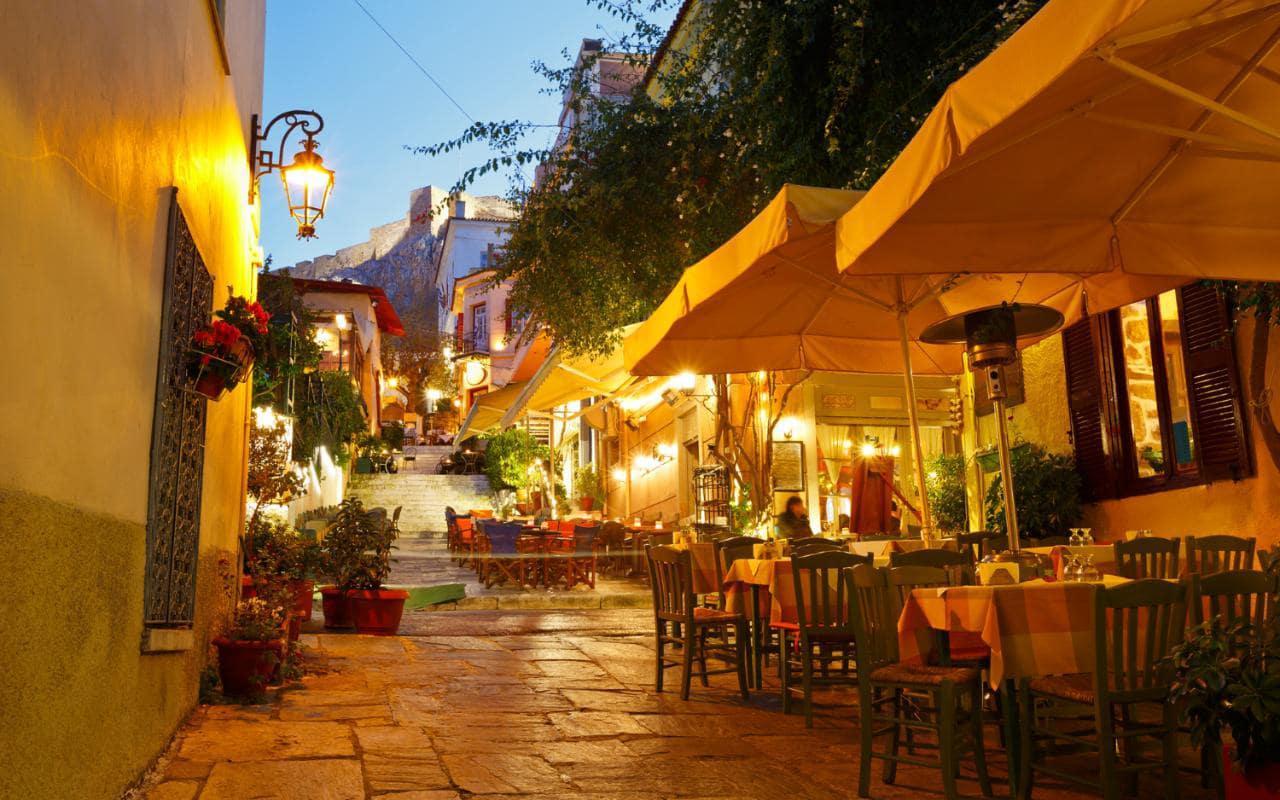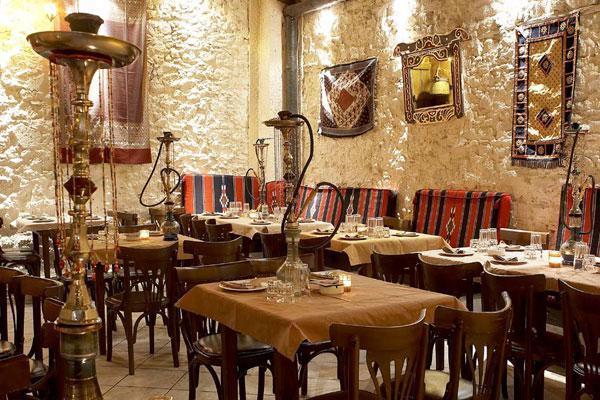The first image is the image on the left, the second image is the image on the right. Given the left and right images, does the statement "The left image features a man standing and facing-forward in the middle of rectangular tables with rail-backed chairs around them." hold true? Answer yes or no. No. The first image is the image on the left, the second image is the image on the right. Assess this claim about the two images: "All of the tables are covered with cloths.". Correct or not? Answer yes or no. Yes. 